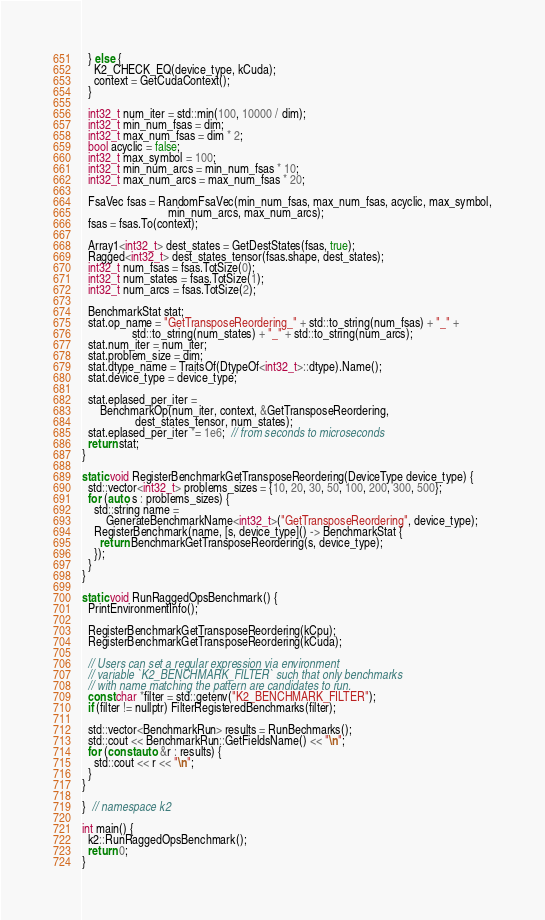<code> <loc_0><loc_0><loc_500><loc_500><_Cuda_>  } else {
    K2_CHECK_EQ(device_type, kCuda);
    context = GetCudaContext();
  }

  int32_t num_iter = std::min(100, 10000 / dim);
  int32_t min_num_fsas = dim;
  int32_t max_num_fsas = dim * 2;
  bool acyclic = false;
  int32_t max_symbol = 100;
  int32_t min_num_arcs = min_num_fsas * 10;
  int32_t max_num_arcs = max_num_fsas * 20;

  FsaVec fsas = RandomFsaVec(min_num_fsas, max_num_fsas, acyclic, max_symbol,
                             min_num_arcs, max_num_arcs);
  fsas = fsas.To(context);

  Array1<int32_t> dest_states = GetDestStates(fsas, true);
  Ragged<int32_t> dest_states_tensor(fsas.shape, dest_states);
  int32_t num_fsas = fsas.TotSize(0);
  int32_t num_states = fsas.TotSize(1);
  int32_t num_arcs = fsas.TotSize(2);

  BenchmarkStat stat;
  stat.op_name = "GetTransposeReordering_" + std::to_string(num_fsas) + "_" +
                 std::to_string(num_states) + "_" + std::to_string(num_arcs);
  stat.num_iter = num_iter;
  stat.problem_size = dim;
  stat.dtype_name = TraitsOf(DtypeOf<int32_t>::dtype).Name();
  stat.device_type = device_type;

  stat.eplased_per_iter =
      BenchmarkOp(num_iter, context, &GetTransposeReordering,
                  dest_states_tensor, num_states);
  stat.eplased_per_iter *= 1e6;  // from seconds to microseconds
  return stat;
}

static void RegisterBenchmarkGetTransposeReordering(DeviceType device_type) {
  std::vector<int32_t> problems_sizes = {10, 20, 30, 50, 100, 200, 300, 500};
  for (auto s : problems_sizes) {
    std::string name =
        GenerateBenchmarkName<int32_t>("GetTransposeReordering", device_type);
    RegisterBenchmark(name, [s, device_type]() -> BenchmarkStat {
      return BenchmarkGetTransposeReordering(s, device_type);
    });
  }
}

static void RunRaggedOpsBenchmark() {
  PrintEnvironmentInfo();

  RegisterBenchmarkGetTransposeReordering(kCpu);
  RegisterBenchmarkGetTransposeReordering(kCuda);

  // Users can set a regular expression via environment
  // variable `K2_BENCHMARK_FILTER` such that only benchmarks
  // with name matching the pattern are candidates to run.
  const char *filter = std::getenv("K2_BENCHMARK_FILTER");
  if (filter != nullptr) FilterRegisteredBenchmarks(filter);

  std::vector<BenchmarkRun> results = RunBechmarks();
  std::cout << BenchmarkRun::GetFieldsName() << "\n";
  for (const auto &r : results) {
    std::cout << r << "\n";
  }
}

}  // namespace k2

int main() {
  k2::RunRaggedOpsBenchmark();
  return 0;
}
</code> 